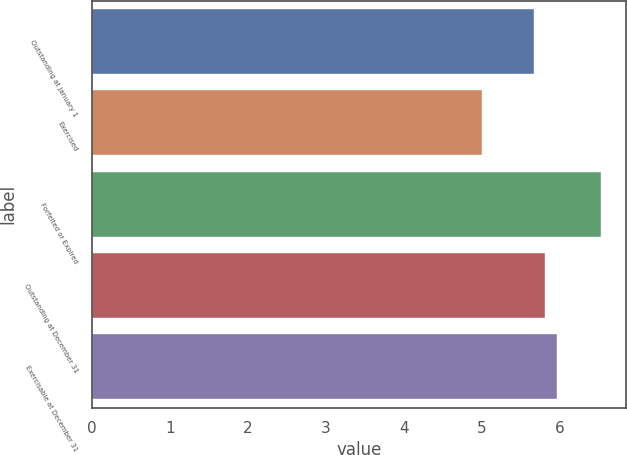Convert chart. <chart><loc_0><loc_0><loc_500><loc_500><bar_chart><fcel>Outstanding at January 1<fcel>Exercised<fcel>Forfeited or Expired<fcel>Outstanding at December 31<fcel>Exercisable at December 31<nl><fcel>5.66<fcel>5<fcel>6.52<fcel>5.81<fcel>5.96<nl></chart> 